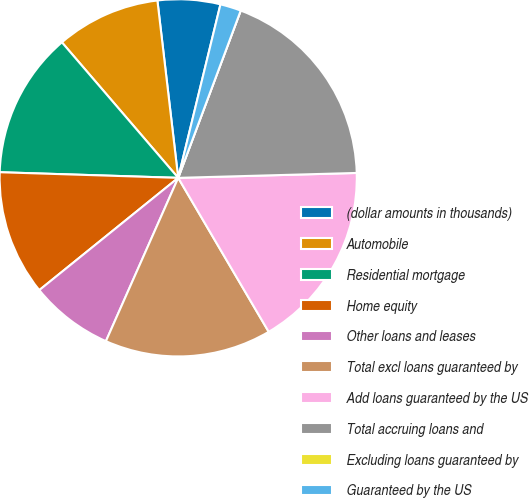<chart> <loc_0><loc_0><loc_500><loc_500><pie_chart><fcel>(dollar amounts in thousands)<fcel>Automobile<fcel>Residential mortgage<fcel>Home equity<fcel>Other loans and leases<fcel>Total excl loans guaranteed by<fcel>Add loans guaranteed by the US<fcel>Total accruing loans and<fcel>Excluding loans guaranteed by<fcel>Guaranteed by the US<nl><fcel>5.66%<fcel>9.43%<fcel>13.21%<fcel>11.32%<fcel>7.55%<fcel>15.09%<fcel>16.98%<fcel>18.87%<fcel>0.0%<fcel>1.89%<nl></chart> 